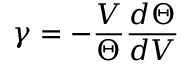Convert formula to latex. <formula><loc_0><loc_0><loc_500><loc_500>\gamma = - \frac { V } { \Theta } \frac { d \Theta } { d V }</formula> 